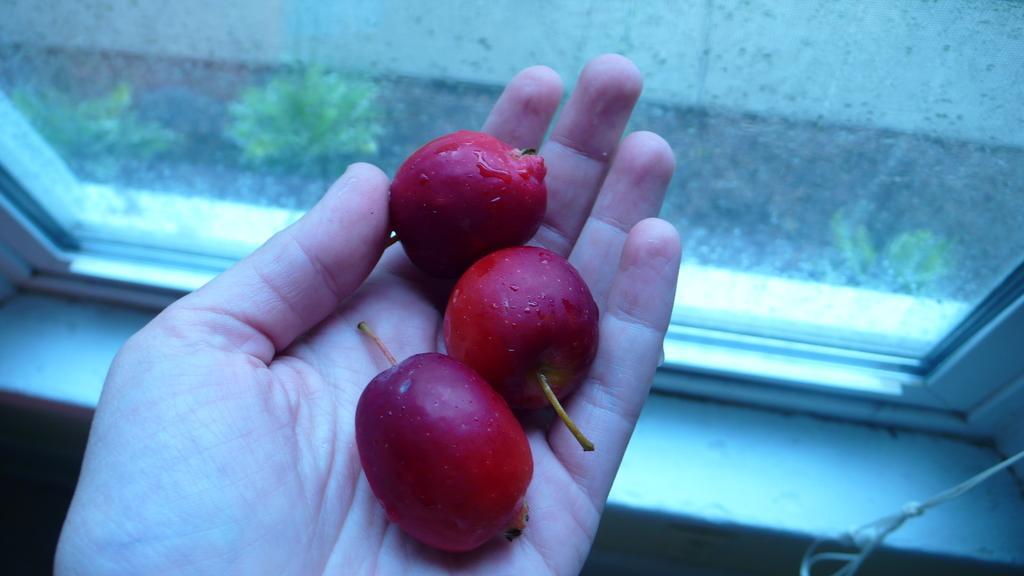Can you describe this image briefly? In this image, we can see fruits on the hand which is in front of the window. 